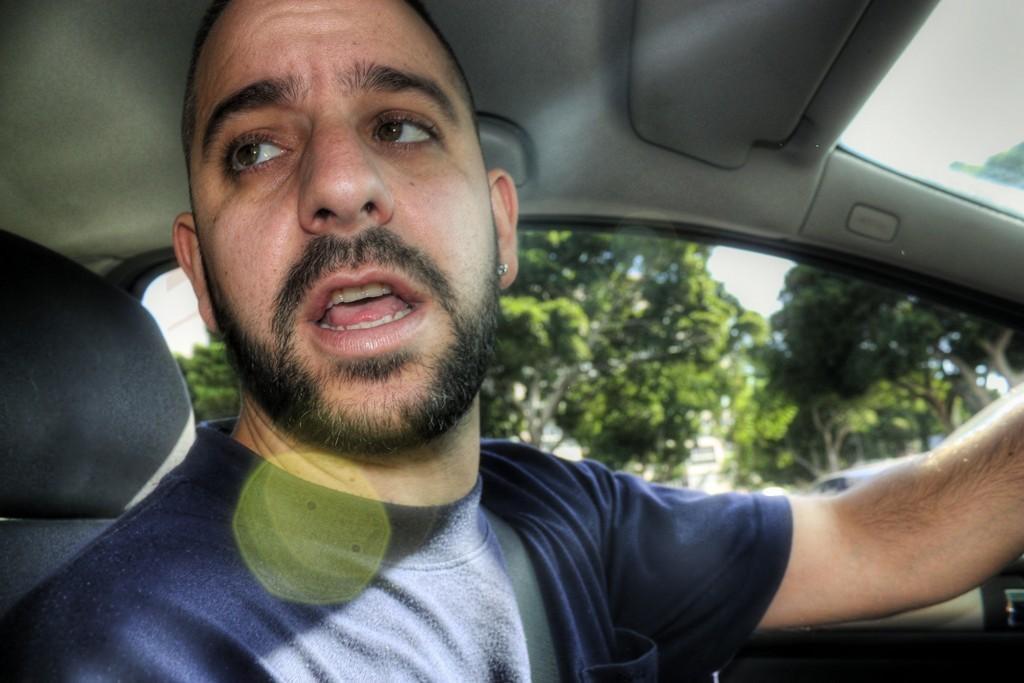Could you give a brief overview of what you see in this image? It is a picture in a vehicle. A man in in blue shirt is sitting in this vehicle. He is talking because his mouth opened. In the background there are trees. Sky is clear and sunny. 